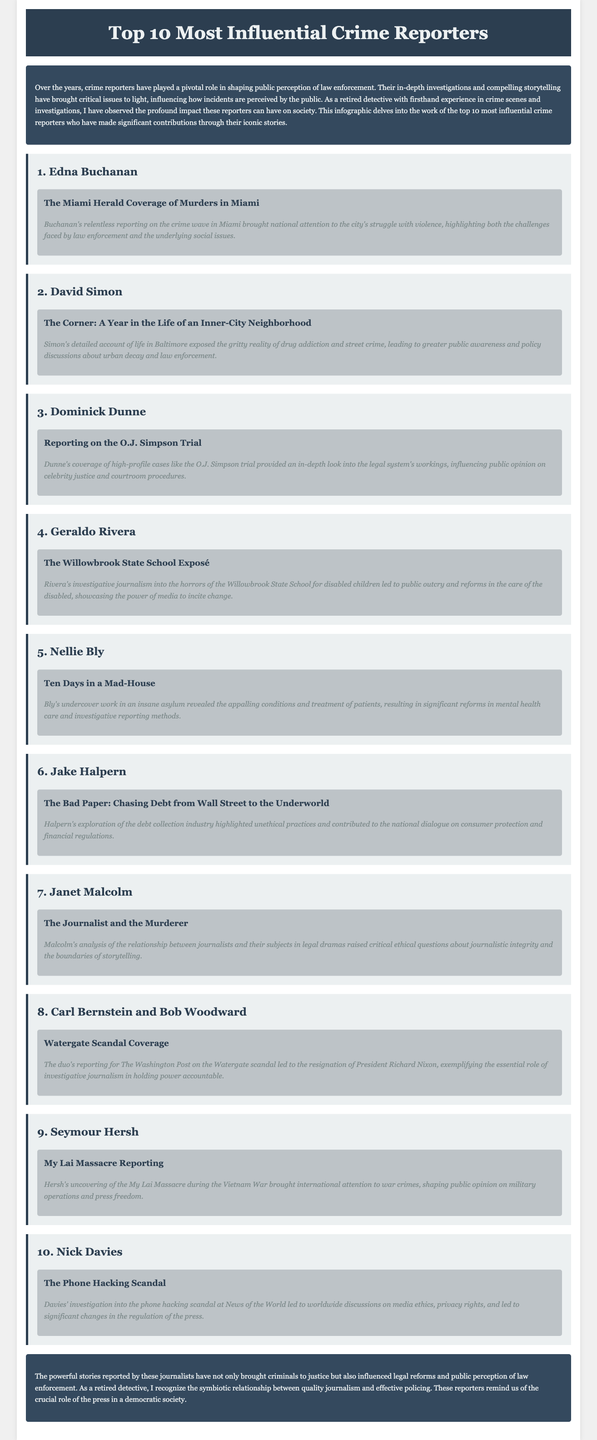What is the title of the document? The title of the document is presented in the header of the webpage.
Answer: Top 10 Most Influential Crime Reporters Who is the first crime reporter listed? The first crime reporter mentioned in the infographic is the one highlighted in the first reporter section.
Answer: Edna Buchanan How many reporters are featured in the document? The document explicitly states the number of reporters listed within the content.
Answer: 10 What was the title of Jake Halpern's story? The title of Halpern's story is contained in the section dedicated to his reporting.
Answer: The Bad Paper: Chasing Debt from Wall Street to the Underworld Which scandal did Carl Bernstein and Bob Woodward cover? The specific scandal they reported on is provided in their respective story section.
Answer: Watergate Scandal What was the impact of Edna Buchanan's reporting? The impact is summarized in the impact description of her story.
Answer: Brought national attention to the city's struggle with violence Why is Janet Malcolm notable according to the infographic? Her significance is explained in the context of her story's theme and implications.
Answer: Raised critical ethical questions about journalistic integrity What type of document is this? The structure and purpose of the content indicate its classification.
Answer: Infographic What major issue did Geraldo Rivera's exposé address? The issue highlighted by Rivera's investigation is clearly indicated in the story section dedicated to him.
Answer: Horrors of the Willowbrook State School 